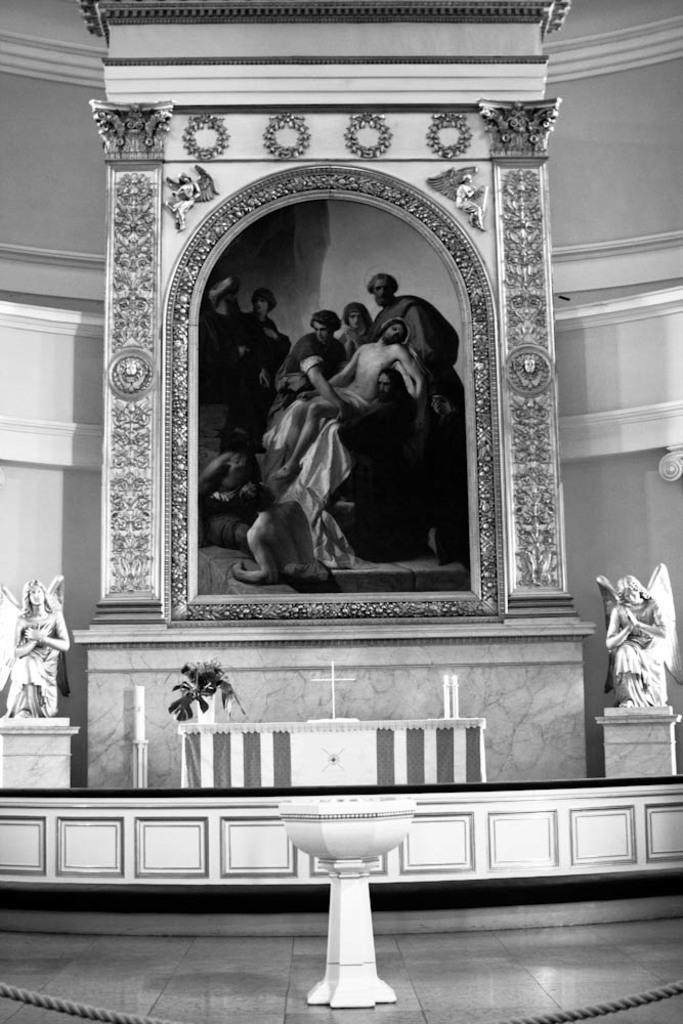Who or what can be seen in the image? There are persons in the image. What is the background or surrounding of the image? There is a designed wall around the image. Are there any additional features or objects near the persons? Yes, there are statues on either side of the image. What is in front of the persons in the image? There are objects in front of the image. What type of rhythm can be heard coming from the leaf in the image? There is no leaf present in the image, so it's not possible to determine if there is any rhythm associated with it. 